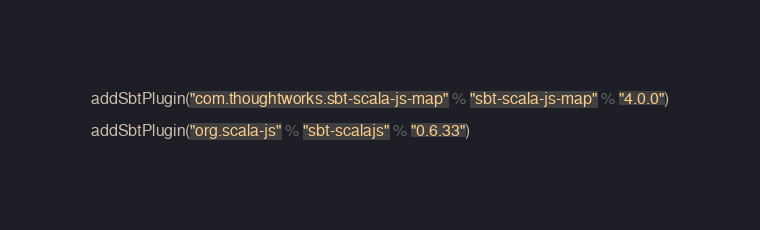Convert code to text. <code><loc_0><loc_0><loc_500><loc_500><_Scala_>addSbtPlugin("com.thoughtworks.sbt-scala-js-map" % "sbt-scala-js-map" % "4.0.0")

addSbtPlugin("org.scala-js" % "sbt-scalajs" % "0.6.33")
</code> 